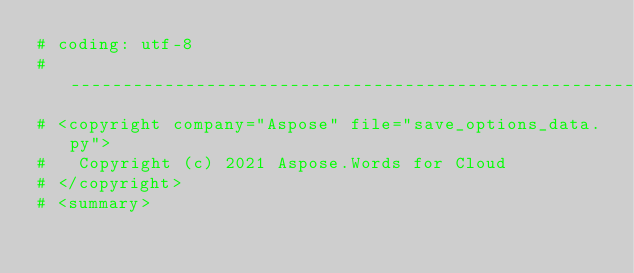<code> <loc_0><loc_0><loc_500><loc_500><_Python_># coding: utf-8
# -----------------------------------------------------------------------------------
# <copyright company="Aspose" file="save_options_data.py">
#   Copyright (c) 2021 Aspose.Words for Cloud
# </copyright>
# <summary></code> 